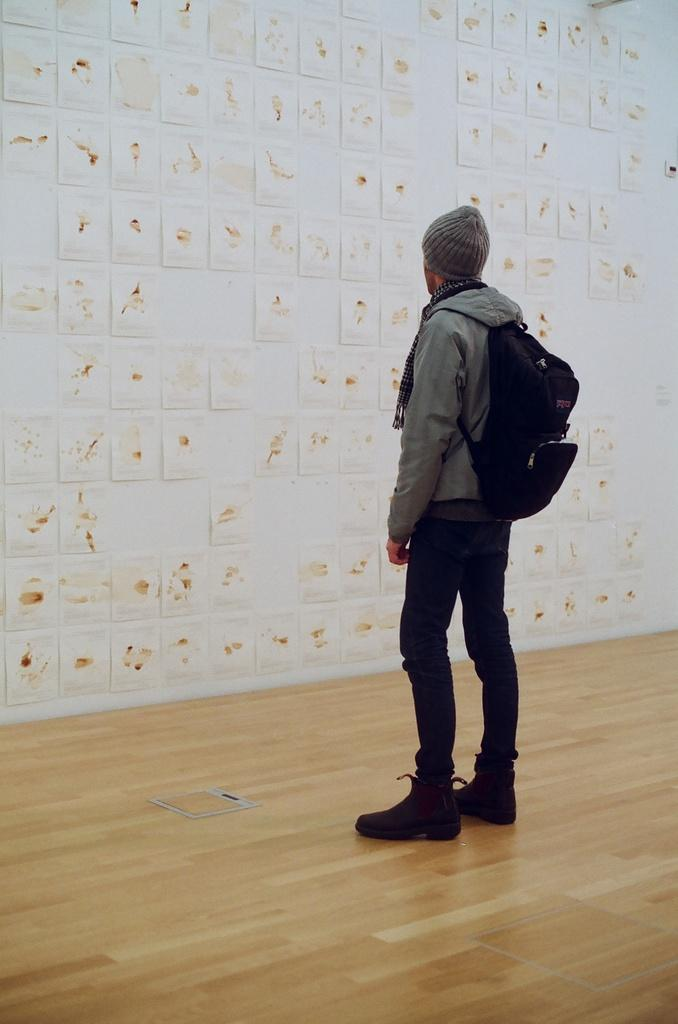Who is present in the image? There is a person in the image. What is the person wearing? The person is wearing a grey jacket. What is the person doing in the image? The person is standing. What can be seen on the wall in the background? There are frames on the wall in the background. What type of flooring is visible in the image? There is a wooden floor in the image. What is the person's role in the government in the image? There is no information about the person's role in the government in the image. 